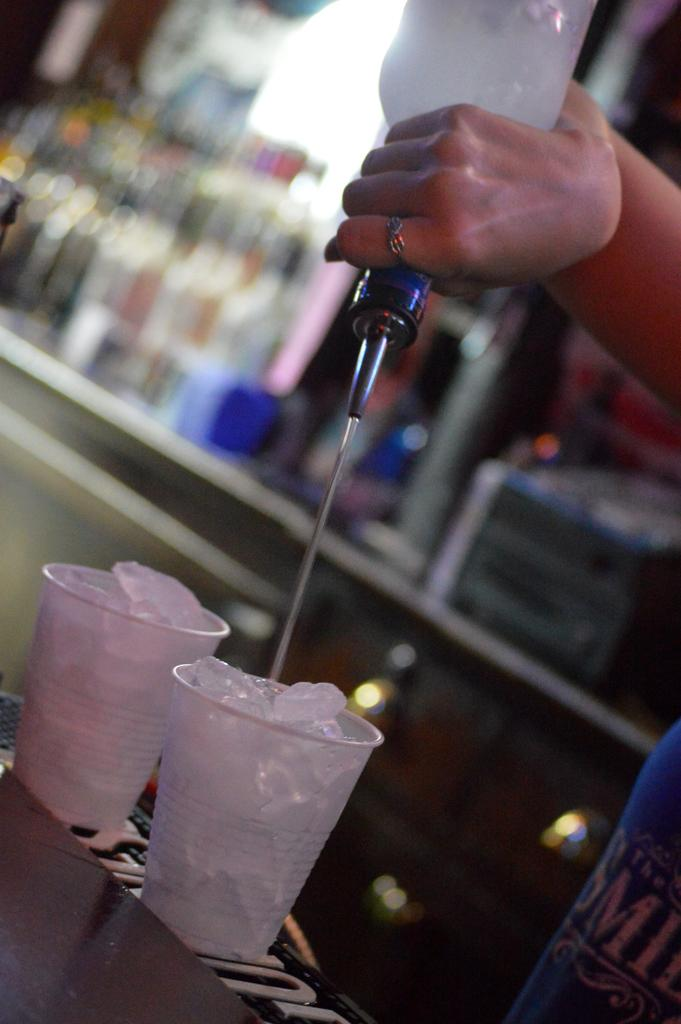What is in the glasses in the image? There are ice cubes in two glasses in the image. What is the person holding in their hand? There is a bottle in someone's hand in the image. Where are additional bottles located in the image? There are bottles on a rack in the image. Can you describe the background of the image? The background of the image is blurred. How does the impulse affect the parent in the image? There is no impulse or parent present in the image; it only features glasses with ice cubes, a bottle in someone's hand, and bottles on a rack. What type of earthquake can be seen in the image? There is no earthquake present in the image; it only features glasses with ice cubes, a bottle in someone's hand, and bottles on a rack. 